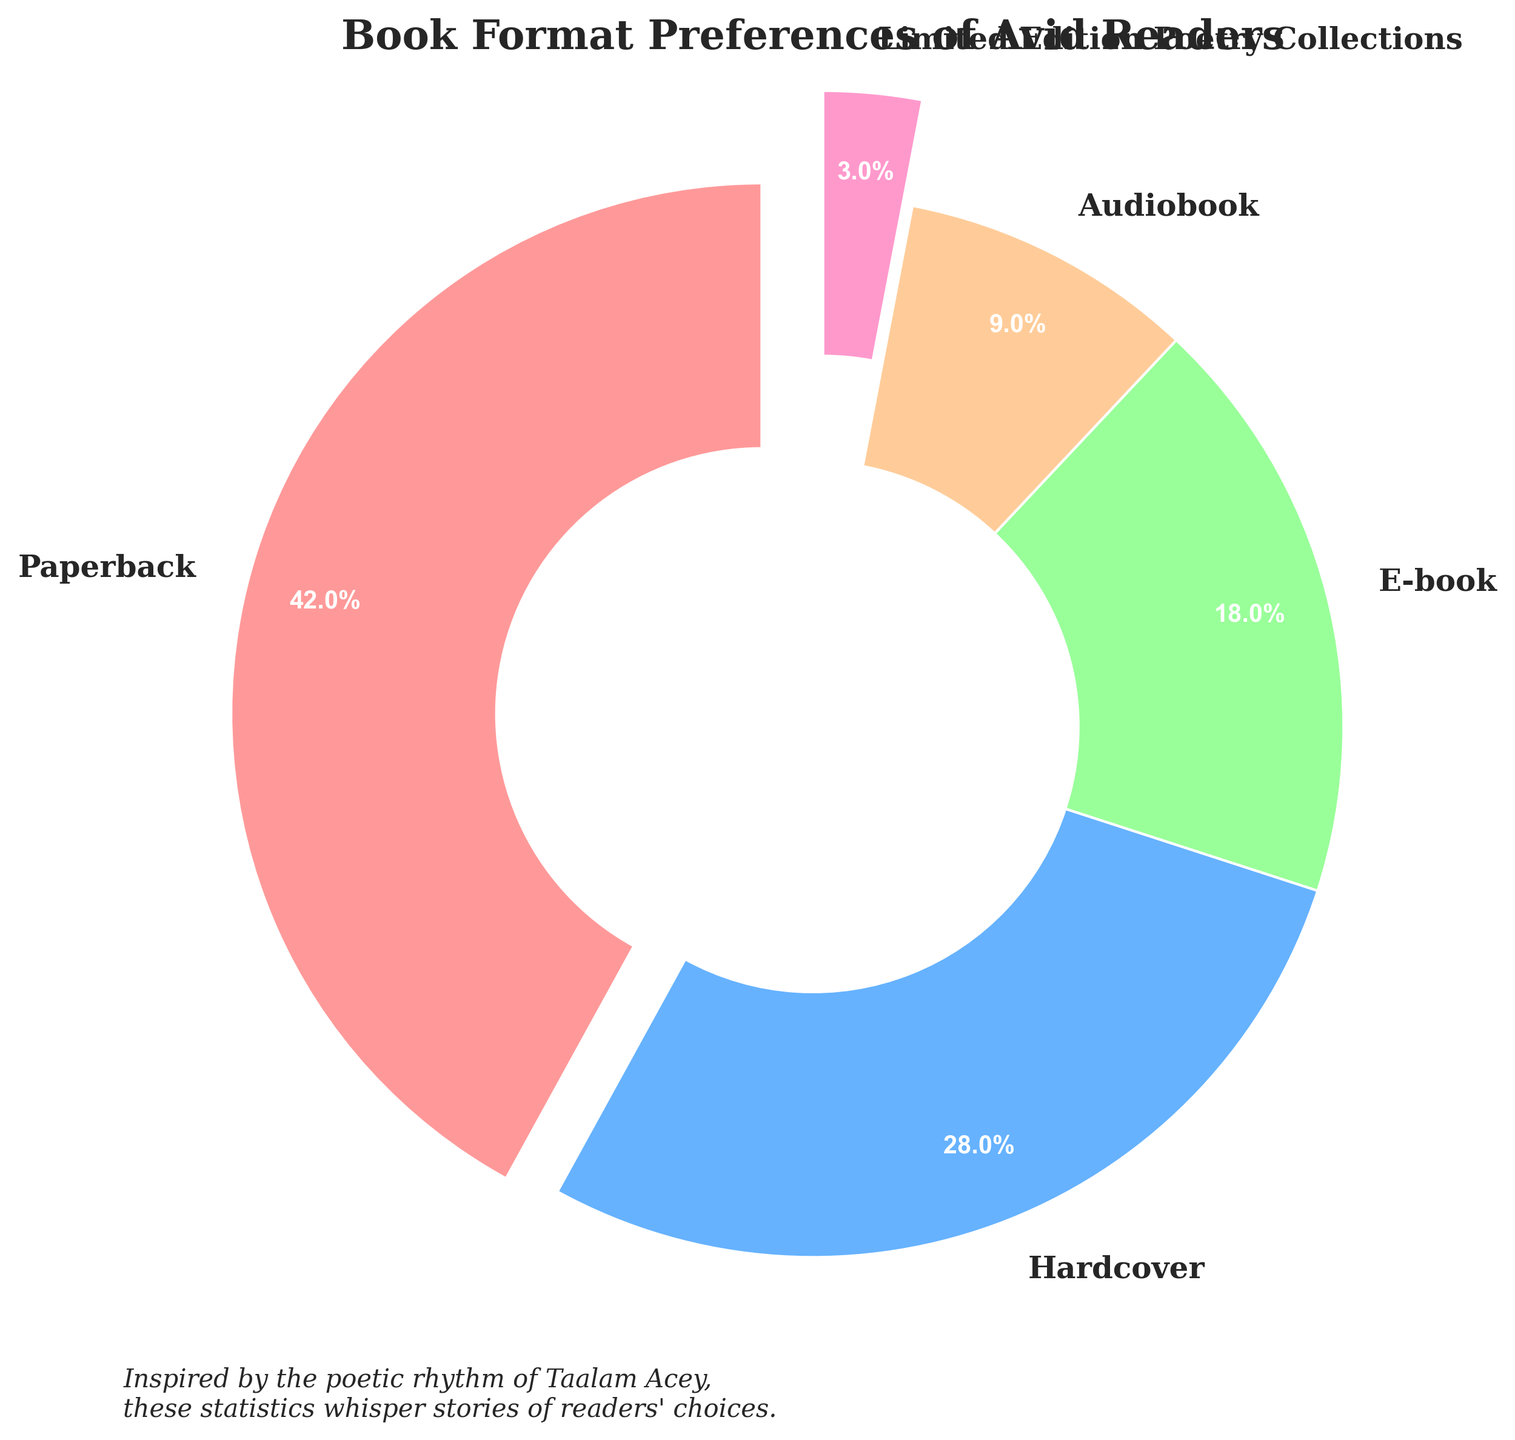What's the most preferred book format among avid readers? The pie chart shows the percentage distribution of different book formats. Looking at the chart, the largest wedge corresponds to the Paperback format at 42%.
Answer: Paperback Which two book formats together make up more than half of the total book purchases? From the percentages, combine the two largest portions. Paperback is 42% and Hardcover is 28%. Together, they total 42% + 28% = 70%, which is more than half.
Answer: Paperback and Hardcover How many more percentage points is Paperback compared to E-book? Compare the percentages of Paperback and E-book. Paperback is 42% and E-book is 18%. The difference is 42% - 18% = 24%.
Answer: 24% What is the combined percentage of E-book and Audiobook formats? Add the percentages of the E-book (18%) and Audiobook (9%) formats together. 18% + 9% = 27%.
Answer: 27% Is Hardcover more popular than Audiobook? Compare the percentage values of Hardcover (28%) and Audiobook (9%). Since 28% is greater than 9%, Hardcover is indeed more popular.
Answer: Yes Among Paperback, Hardcover, and E-book, which format occupies the smallest proportion in the chart? Compare the percentages among Paperback (42%), Hardcover (28%), and E-book (18%). E-book has the smallest percentage among the three.
Answer: E-book How many times is the percentage of Audiobook compared to Limited Edition Poetry Collections? First, determine the percentages: Audiobook is 9% and Limited Edition Poetry Collections is 3%. Divide 9% by 3% to get the ratio, which is 9% / 3% = 3 times.
Answer: 3 times If the Paperback and Hardcover categories were combined into a single category, what would be its new percentage, and would it still be the largest category? Sum the percentages of Paperback (42%) and Hardcover (28%) to get 42% + 28% = 70%. Compare this with the next largest category, Paperback alone (42%). Since 70% is larger, it would still be the largest.
Answer: 70%, Yes What is the percentage difference between the most and least preferred book formats? Identify the most and least preferred formats: Paperback is 42%, and Limited Edition Poetry Collections is 3%. The difference is 42% - 3% = 39%.
Answer: 39% 